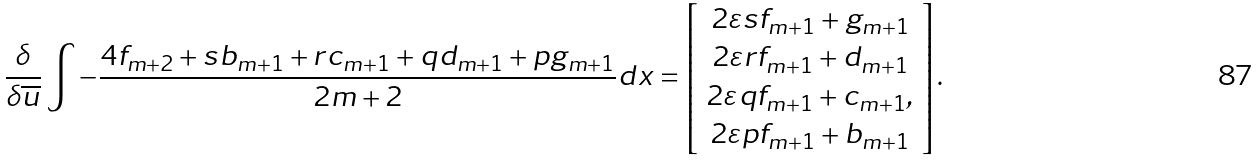<formula> <loc_0><loc_0><loc_500><loc_500>\frac { \delta } { \delta \overline { u } } \int - \frac { 4 f _ { m + 2 } + s b _ { m + 1 } + r c _ { m + 1 } + q d _ { m + 1 } + p g _ { m + 1 } } { 2 m + 2 } d x = \left [ \begin{array} { c } 2 \varepsilon s f _ { m + 1 } + g _ { m + 1 } \\ 2 \varepsilon r f _ { m + 1 } + d _ { m + 1 } \\ 2 \varepsilon q f _ { m + 1 } + c _ { m + 1 } , \\ 2 \varepsilon p f _ { m + 1 } + b _ { m + 1 } \end{array} \right ] .</formula> 